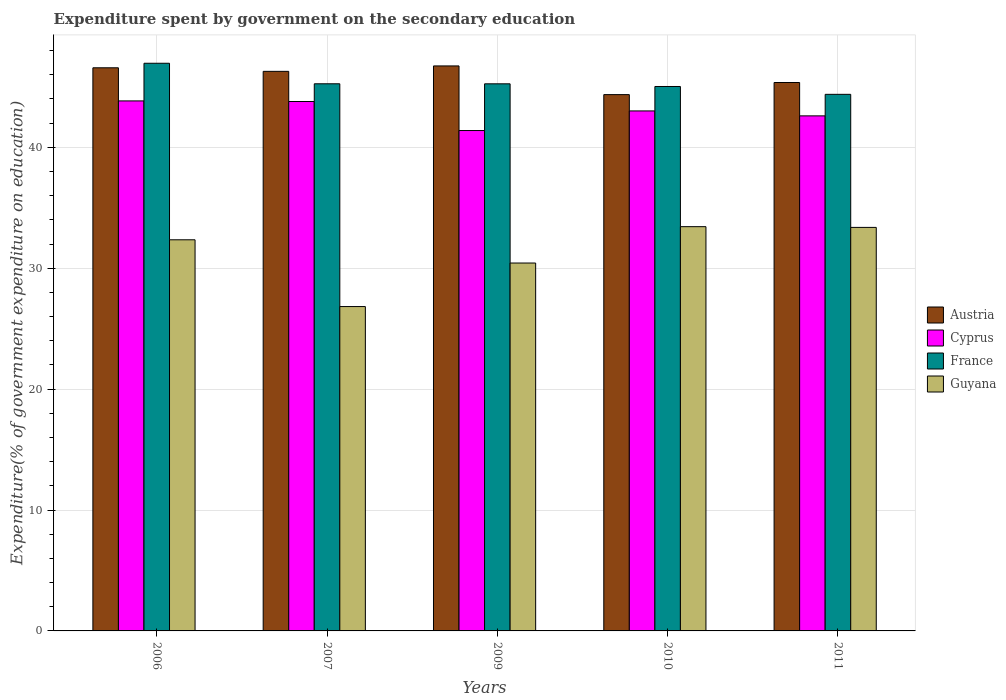How many different coloured bars are there?
Offer a very short reply. 4. How many groups of bars are there?
Your answer should be compact. 5. How many bars are there on the 4th tick from the right?
Offer a terse response. 4. What is the expenditure spent by government on the secondary education in Austria in 2009?
Offer a very short reply. 46.73. Across all years, what is the maximum expenditure spent by government on the secondary education in Austria?
Provide a succinct answer. 46.73. Across all years, what is the minimum expenditure spent by government on the secondary education in France?
Your response must be concise. 44.38. What is the total expenditure spent by government on the secondary education in France in the graph?
Offer a terse response. 226.88. What is the difference between the expenditure spent by government on the secondary education in Guyana in 2006 and that in 2011?
Give a very brief answer. -1.02. What is the difference between the expenditure spent by government on the secondary education in Austria in 2007 and the expenditure spent by government on the secondary education in Guyana in 2011?
Your response must be concise. 12.91. What is the average expenditure spent by government on the secondary education in Austria per year?
Give a very brief answer. 45.86. In the year 2010, what is the difference between the expenditure spent by government on the secondary education in France and expenditure spent by government on the secondary education in Cyprus?
Offer a very short reply. 2.02. In how many years, is the expenditure spent by government on the secondary education in Cyprus greater than 42 %?
Provide a succinct answer. 4. What is the ratio of the expenditure spent by government on the secondary education in Cyprus in 2009 to that in 2011?
Offer a terse response. 0.97. What is the difference between the highest and the second highest expenditure spent by government on the secondary education in Austria?
Offer a very short reply. 0.15. What is the difference between the highest and the lowest expenditure spent by government on the secondary education in Austria?
Offer a terse response. 2.37. In how many years, is the expenditure spent by government on the secondary education in France greater than the average expenditure spent by government on the secondary education in France taken over all years?
Offer a very short reply. 1. Is it the case that in every year, the sum of the expenditure spent by government on the secondary education in France and expenditure spent by government on the secondary education in Austria is greater than the sum of expenditure spent by government on the secondary education in Guyana and expenditure spent by government on the secondary education in Cyprus?
Make the answer very short. Yes. What does the 3rd bar from the left in 2006 represents?
Provide a succinct answer. France. What does the 1st bar from the right in 2009 represents?
Your response must be concise. Guyana. Is it the case that in every year, the sum of the expenditure spent by government on the secondary education in France and expenditure spent by government on the secondary education in Austria is greater than the expenditure spent by government on the secondary education in Guyana?
Provide a succinct answer. Yes. Are all the bars in the graph horizontal?
Provide a short and direct response. No. How many years are there in the graph?
Your answer should be compact. 5. Does the graph contain grids?
Give a very brief answer. Yes. Where does the legend appear in the graph?
Make the answer very short. Center right. How are the legend labels stacked?
Provide a succinct answer. Vertical. What is the title of the graph?
Give a very brief answer. Expenditure spent by government on the secondary education. Does "Lao PDR" appear as one of the legend labels in the graph?
Your answer should be very brief. No. What is the label or title of the Y-axis?
Make the answer very short. Expenditure(% of government expenditure on education). What is the Expenditure(% of government expenditure on education) of Austria in 2006?
Offer a very short reply. 46.58. What is the Expenditure(% of government expenditure on education) of Cyprus in 2006?
Ensure brevity in your answer.  43.84. What is the Expenditure(% of government expenditure on education) of France in 2006?
Provide a succinct answer. 46.95. What is the Expenditure(% of government expenditure on education) in Guyana in 2006?
Your answer should be very brief. 32.35. What is the Expenditure(% of government expenditure on education) of Austria in 2007?
Provide a succinct answer. 46.28. What is the Expenditure(% of government expenditure on education) in Cyprus in 2007?
Provide a short and direct response. 43.79. What is the Expenditure(% of government expenditure on education) of France in 2007?
Give a very brief answer. 45.26. What is the Expenditure(% of government expenditure on education) of Guyana in 2007?
Ensure brevity in your answer.  26.83. What is the Expenditure(% of government expenditure on education) of Austria in 2009?
Make the answer very short. 46.73. What is the Expenditure(% of government expenditure on education) of Cyprus in 2009?
Provide a short and direct response. 41.39. What is the Expenditure(% of government expenditure on education) in France in 2009?
Keep it short and to the point. 45.25. What is the Expenditure(% of government expenditure on education) in Guyana in 2009?
Offer a terse response. 30.43. What is the Expenditure(% of government expenditure on education) in Austria in 2010?
Ensure brevity in your answer.  44.36. What is the Expenditure(% of government expenditure on education) of Cyprus in 2010?
Provide a succinct answer. 43.01. What is the Expenditure(% of government expenditure on education) of France in 2010?
Provide a succinct answer. 45.03. What is the Expenditure(% of government expenditure on education) of Guyana in 2010?
Make the answer very short. 33.44. What is the Expenditure(% of government expenditure on education) in Austria in 2011?
Provide a succinct answer. 45.36. What is the Expenditure(% of government expenditure on education) of Cyprus in 2011?
Your answer should be very brief. 42.6. What is the Expenditure(% of government expenditure on education) in France in 2011?
Provide a short and direct response. 44.38. What is the Expenditure(% of government expenditure on education) in Guyana in 2011?
Your answer should be very brief. 33.38. Across all years, what is the maximum Expenditure(% of government expenditure on education) in Austria?
Provide a succinct answer. 46.73. Across all years, what is the maximum Expenditure(% of government expenditure on education) in Cyprus?
Your answer should be very brief. 43.84. Across all years, what is the maximum Expenditure(% of government expenditure on education) of France?
Your answer should be compact. 46.95. Across all years, what is the maximum Expenditure(% of government expenditure on education) in Guyana?
Ensure brevity in your answer.  33.44. Across all years, what is the minimum Expenditure(% of government expenditure on education) of Austria?
Provide a short and direct response. 44.36. Across all years, what is the minimum Expenditure(% of government expenditure on education) of Cyprus?
Your answer should be very brief. 41.39. Across all years, what is the minimum Expenditure(% of government expenditure on education) of France?
Your response must be concise. 44.38. Across all years, what is the minimum Expenditure(% of government expenditure on education) in Guyana?
Your answer should be compact. 26.83. What is the total Expenditure(% of government expenditure on education) in Austria in the graph?
Make the answer very short. 229.32. What is the total Expenditure(% of government expenditure on education) in Cyprus in the graph?
Your answer should be very brief. 214.63. What is the total Expenditure(% of government expenditure on education) in France in the graph?
Offer a very short reply. 226.88. What is the total Expenditure(% of government expenditure on education) in Guyana in the graph?
Give a very brief answer. 156.43. What is the difference between the Expenditure(% of government expenditure on education) in Austria in 2006 and that in 2007?
Ensure brevity in your answer.  0.29. What is the difference between the Expenditure(% of government expenditure on education) of Cyprus in 2006 and that in 2007?
Keep it short and to the point. 0.05. What is the difference between the Expenditure(% of government expenditure on education) of France in 2006 and that in 2007?
Provide a short and direct response. 1.7. What is the difference between the Expenditure(% of government expenditure on education) of Guyana in 2006 and that in 2007?
Provide a short and direct response. 5.52. What is the difference between the Expenditure(% of government expenditure on education) of Austria in 2006 and that in 2009?
Your answer should be very brief. -0.15. What is the difference between the Expenditure(% of government expenditure on education) in Cyprus in 2006 and that in 2009?
Your response must be concise. 2.45. What is the difference between the Expenditure(% of government expenditure on education) of France in 2006 and that in 2009?
Your answer should be very brief. 1.7. What is the difference between the Expenditure(% of government expenditure on education) in Guyana in 2006 and that in 2009?
Your response must be concise. 1.92. What is the difference between the Expenditure(% of government expenditure on education) of Austria in 2006 and that in 2010?
Ensure brevity in your answer.  2.22. What is the difference between the Expenditure(% of government expenditure on education) of Cyprus in 2006 and that in 2010?
Your response must be concise. 0.83. What is the difference between the Expenditure(% of government expenditure on education) in France in 2006 and that in 2010?
Keep it short and to the point. 1.92. What is the difference between the Expenditure(% of government expenditure on education) in Guyana in 2006 and that in 2010?
Your answer should be compact. -1.09. What is the difference between the Expenditure(% of government expenditure on education) of Austria in 2006 and that in 2011?
Give a very brief answer. 1.22. What is the difference between the Expenditure(% of government expenditure on education) of Cyprus in 2006 and that in 2011?
Ensure brevity in your answer.  1.24. What is the difference between the Expenditure(% of government expenditure on education) in France in 2006 and that in 2011?
Provide a short and direct response. 2.57. What is the difference between the Expenditure(% of government expenditure on education) of Guyana in 2006 and that in 2011?
Your response must be concise. -1.02. What is the difference between the Expenditure(% of government expenditure on education) in Austria in 2007 and that in 2009?
Offer a very short reply. -0.45. What is the difference between the Expenditure(% of government expenditure on education) in Cyprus in 2007 and that in 2009?
Your response must be concise. 2.4. What is the difference between the Expenditure(% of government expenditure on education) in France in 2007 and that in 2009?
Your answer should be very brief. 0. What is the difference between the Expenditure(% of government expenditure on education) of Guyana in 2007 and that in 2009?
Your answer should be compact. -3.6. What is the difference between the Expenditure(% of government expenditure on education) of Austria in 2007 and that in 2010?
Offer a very short reply. 1.92. What is the difference between the Expenditure(% of government expenditure on education) in Cyprus in 2007 and that in 2010?
Keep it short and to the point. 0.78. What is the difference between the Expenditure(% of government expenditure on education) in France in 2007 and that in 2010?
Make the answer very short. 0.22. What is the difference between the Expenditure(% of government expenditure on education) of Guyana in 2007 and that in 2010?
Your answer should be compact. -6.61. What is the difference between the Expenditure(% of government expenditure on education) of Austria in 2007 and that in 2011?
Your answer should be compact. 0.92. What is the difference between the Expenditure(% of government expenditure on education) of Cyprus in 2007 and that in 2011?
Keep it short and to the point. 1.19. What is the difference between the Expenditure(% of government expenditure on education) in France in 2007 and that in 2011?
Give a very brief answer. 0.87. What is the difference between the Expenditure(% of government expenditure on education) in Guyana in 2007 and that in 2011?
Give a very brief answer. -6.55. What is the difference between the Expenditure(% of government expenditure on education) in Austria in 2009 and that in 2010?
Ensure brevity in your answer.  2.37. What is the difference between the Expenditure(% of government expenditure on education) of Cyprus in 2009 and that in 2010?
Ensure brevity in your answer.  -1.62. What is the difference between the Expenditure(% of government expenditure on education) of France in 2009 and that in 2010?
Offer a very short reply. 0.22. What is the difference between the Expenditure(% of government expenditure on education) of Guyana in 2009 and that in 2010?
Your answer should be compact. -3.01. What is the difference between the Expenditure(% of government expenditure on education) of Austria in 2009 and that in 2011?
Offer a terse response. 1.37. What is the difference between the Expenditure(% of government expenditure on education) in Cyprus in 2009 and that in 2011?
Your answer should be very brief. -1.21. What is the difference between the Expenditure(% of government expenditure on education) in France in 2009 and that in 2011?
Provide a succinct answer. 0.87. What is the difference between the Expenditure(% of government expenditure on education) in Guyana in 2009 and that in 2011?
Your response must be concise. -2.95. What is the difference between the Expenditure(% of government expenditure on education) of Austria in 2010 and that in 2011?
Keep it short and to the point. -1. What is the difference between the Expenditure(% of government expenditure on education) in Cyprus in 2010 and that in 2011?
Your response must be concise. 0.41. What is the difference between the Expenditure(% of government expenditure on education) in France in 2010 and that in 2011?
Your answer should be compact. 0.65. What is the difference between the Expenditure(% of government expenditure on education) of Guyana in 2010 and that in 2011?
Keep it short and to the point. 0.06. What is the difference between the Expenditure(% of government expenditure on education) of Austria in 2006 and the Expenditure(% of government expenditure on education) of Cyprus in 2007?
Ensure brevity in your answer.  2.79. What is the difference between the Expenditure(% of government expenditure on education) in Austria in 2006 and the Expenditure(% of government expenditure on education) in France in 2007?
Provide a succinct answer. 1.32. What is the difference between the Expenditure(% of government expenditure on education) of Austria in 2006 and the Expenditure(% of government expenditure on education) of Guyana in 2007?
Provide a short and direct response. 19.75. What is the difference between the Expenditure(% of government expenditure on education) of Cyprus in 2006 and the Expenditure(% of government expenditure on education) of France in 2007?
Keep it short and to the point. -1.42. What is the difference between the Expenditure(% of government expenditure on education) in Cyprus in 2006 and the Expenditure(% of government expenditure on education) in Guyana in 2007?
Your answer should be very brief. 17.01. What is the difference between the Expenditure(% of government expenditure on education) of France in 2006 and the Expenditure(% of government expenditure on education) of Guyana in 2007?
Provide a short and direct response. 20.12. What is the difference between the Expenditure(% of government expenditure on education) of Austria in 2006 and the Expenditure(% of government expenditure on education) of Cyprus in 2009?
Your answer should be compact. 5.19. What is the difference between the Expenditure(% of government expenditure on education) of Austria in 2006 and the Expenditure(% of government expenditure on education) of France in 2009?
Provide a short and direct response. 1.33. What is the difference between the Expenditure(% of government expenditure on education) of Austria in 2006 and the Expenditure(% of government expenditure on education) of Guyana in 2009?
Provide a succinct answer. 16.15. What is the difference between the Expenditure(% of government expenditure on education) in Cyprus in 2006 and the Expenditure(% of government expenditure on education) in France in 2009?
Your answer should be very brief. -1.41. What is the difference between the Expenditure(% of government expenditure on education) in Cyprus in 2006 and the Expenditure(% of government expenditure on education) in Guyana in 2009?
Your answer should be compact. 13.41. What is the difference between the Expenditure(% of government expenditure on education) in France in 2006 and the Expenditure(% of government expenditure on education) in Guyana in 2009?
Provide a succinct answer. 16.52. What is the difference between the Expenditure(% of government expenditure on education) in Austria in 2006 and the Expenditure(% of government expenditure on education) in Cyprus in 2010?
Your answer should be very brief. 3.57. What is the difference between the Expenditure(% of government expenditure on education) in Austria in 2006 and the Expenditure(% of government expenditure on education) in France in 2010?
Your response must be concise. 1.55. What is the difference between the Expenditure(% of government expenditure on education) in Austria in 2006 and the Expenditure(% of government expenditure on education) in Guyana in 2010?
Give a very brief answer. 13.14. What is the difference between the Expenditure(% of government expenditure on education) in Cyprus in 2006 and the Expenditure(% of government expenditure on education) in France in 2010?
Give a very brief answer. -1.19. What is the difference between the Expenditure(% of government expenditure on education) in Cyprus in 2006 and the Expenditure(% of government expenditure on education) in Guyana in 2010?
Ensure brevity in your answer.  10.4. What is the difference between the Expenditure(% of government expenditure on education) in France in 2006 and the Expenditure(% of government expenditure on education) in Guyana in 2010?
Keep it short and to the point. 13.52. What is the difference between the Expenditure(% of government expenditure on education) of Austria in 2006 and the Expenditure(% of government expenditure on education) of Cyprus in 2011?
Your answer should be compact. 3.98. What is the difference between the Expenditure(% of government expenditure on education) in Austria in 2006 and the Expenditure(% of government expenditure on education) in France in 2011?
Keep it short and to the point. 2.2. What is the difference between the Expenditure(% of government expenditure on education) in Austria in 2006 and the Expenditure(% of government expenditure on education) in Guyana in 2011?
Keep it short and to the point. 13.2. What is the difference between the Expenditure(% of government expenditure on education) of Cyprus in 2006 and the Expenditure(% of government expenditure on education) of France in 2011?
Provide a succinct answer. -0.54. What is the difference between the Expenditure(% of government expenditure on education) in Cyprus in 2006 and the Expenditure(% of government expenditure on education) in Guyana in 2011?
Your answer should be very brief. 10.46. What is the difference between the Expenditure(% of government expenditure on education) in France in 2006 and the Expenditure(% of government expenditure on education) in Guyana in 2011?
Provide a short and direct response. 13.58. What is the difference between the Expenditure(% of government expenditure on education) in Austria in 2007 and the Expenditure(% of government expenditure on education) in Cyprus in 2009?
Your response must be concise. 4.89. What is the difference between the Expenditure(% of government expenditure on education) in Austria in 2007 and the Expenditure(% of government expenditure on education) in France in 2009?
Your answer should be very brief. 1.03. What is the difference between the Expenditure(% of government expenditure on education) in Austria in 2007 and the Expenditure(% of government expenditure on education) in Guyana in 2009?
Provide a succinct answer. 15.85. What is the difference between the Expenditure(% of government expenditure on education) of Cyprus in 2007 and the Expenditure(% of government expenditure on education) of France in 2009?
Make the answer very short. -1.46. What is the difference between the Expenditure(% of government expenditure on education) in Cyprus in 2007 and the Expenditure(% of government expenditure on education) in Guyana in 2009?
Your response must be concise. 13.36. What is the difference between the Expenditure(% of government expenditure on education) in France in 2007 and the Expenditure(% of government expenditure on education) in Guyana in 2009?
Provide a succinct answer. 14.83. What is the difference between the Expenditure(% of government expenditure on education) of Austria in 2007 and the Expenditure(% of government expenditure on education) of Cyprus in 2010?
Your response must be concise. 3.27. What is the difference between the Expenditure(% of government expenditure on education) in Austria in 2007 and the Expenditure(% of government expenditure on education) in France in 2010?
Your response must be concise. 1.25. What is the difference between the Expenditure(% of government expenditure on education) in Austria in 2007 and the Expenditure(% of government expenditure on education) in Guyana in 2010?
Keep it short and to the point. 12.85. What is the difference between the Expenditure(% of government expenditure on education) in Cyprus in 2007 and the Expenditure(% of government expenditure on education) in France in 2010?
Provide a short and direct response. -1.24. What is the difference between the Expenditure(% of government expenditure on education) in Cyprus in 2007 and the Expenditure(% of government expenditure on education) in Guyana in 2010?
Provide a succinct answer. 10.35. What is the difference between the Expenditure(% of government expenditure on education) of France in 2007 and the Expenditure(% of government expenditure on education) of Guyana in 2010?
Provide a succinct answer. 11.82. What is the difference between the Expenditure(% of government expenditure on education) of Austria in 2007 and the Expenditure(% of government expenditure on education) of Cyprus in 2011?
Offer a very short reply. 3.68. What is the difference between the Expenditure(% of government expenditure on education) in Austria in 2007 and the Expenditure(% of government expenditure on education) in France in 2011?
Offer a very short reply. 1.9. What is the difference between the Expenditure(% of government expenditure on education) of Austria in 2007 and the Expenditure(% of government expenditure on education) of Guyana in 2011?
Provide a succinct answer. 12.91. What is the difference between the Expenditure(% of government expenditure on education) of Cyprus in 2007 and the Expenditure(% of government expenditure on education) of France in 2011?
Give a very brief answer. -0.59. What is the difference between the Expenditure(% of government expenditure on education) in Cyprus in 2007 and the Expenditure(% of government expenditure on education) in Guyana in 2011?
Provide a succinct answer. 10.41. What is the difference between the Expenditure(% of government expenditure on education) in France in 2007 and the Expenditure(% of government expenditure on education) in Guyana in 2011?
Your answer should be very brief. 11.88. What is the difference between the Expenditure(% of government expenditure on education) of Austria in 2009 and the Expenditure(% of government expenditure on education) of Cyprus in 2010?
Offer a very short reply. 3.72. What is the difference between the Expenditure(% of government expenditure on education) in Austria in 2009 and the Expenditure(% of government expenditure on education) in France in 2010?
Give a very brief answer. 1.7. What is the difference between the Expenditure(% of government expenditure on education) in Austria in 2009 and the Expenditure(% of government expenditure on education) in Guyana in 2010?
Offer a terse response. 13.29. What is the difference between the Expenditure(% of government expenditure on education) in Cyprus in 2009 and the Expenditure(% of government expenditure on education) in France in 2010?
Provide a succinct answer. -3.64. What is the difference between the Expenditure(% of government expenditure on education) in Cyprus in 2009 and the Expenditure(% of government expenditure on education) in Guyana in 2010?
Offer a terse response. 7.95. What is the difference between the Expenditure(% of government expenditure on education) of France in 2009 and the Expenditure(% of government expenditure on education) of Guyana in 2010?
Your answer should be very brief. 11.82. What is the difference between the Expenditure(% of government expenditure on education) of Austria in 2009 and the Expenditure(% of government expenditure on education) of Cyprus in 2011?
Provide a short and direct response. 4.13. What is the difference between the Expenditure(% of government expenditure on education) of Austria in 2009 and the Expenditure(% of government expenditure on education) of France in 2011?
Your response must be concise. 2.35. What is the difference between the Expenditure(% of government expenditure on education) in Austria in 2009 and the Expenditure(% of government expenditure on education) in Guyana in 2011?
Offer a terse response. 13.36. What is the difference between the Expenditure(% of government expenditure on education) in Cyprus in 2009 and the Expenditure(% of government expenditure on education) in France in 2011?
Keep it short and to the point. -2.99. What is the difference between the Expenditure(% of government expenditure on education) of Cyprus in 2009 and the Expenditure(% of government expenditure on education) of Guyana in 2011?
Your answer should be compact. 8.01. What is the difference between the Expenditure(% of government expenditure on education) in France in 2009 and the Expenditure(% of government expenditure on education) in Guyana in 2011?
Provide a short and direct response. 11.88. What is the difference between the Expenditure(% of government expenditure on education) of Austria in 2010 and the Expenditure(% of government expenditure on education) of Cyprus in 2011?
Offer a terse response. 1.76. What is the difference between the Expenditure(% of government expenditure on education) in Austria in 2010 and the Expenditure(% of government expenditure on education) in France in 2011?
Your response must be concise. -0.02. What is the difference between the Expenditure(% of government expenditure on education) of Austria in 2010 and the Expenditure(% of government expenditure on education) of Guyana in 2011?
Offer a terse response. 10.98. What is the difference between the Expenditure(% of government expenditure on education) of Cyprus in 2010 and the Expenditure(% of government expenditure on education) of France in 2011?
Your answer should be very brief. -1.37. What is the difference between the Expenditure(% of government expenditure on education) of Cyprus in 2010 and the Expenditure(% of government expenditure on education) of Guyana in 2011?
Keep it short and to the point. 9.63. What is the difference between the Expenditure(% of government expenditure on education) of France in 2010 and the Expenditure(% of government expenditure on education) of Guyana in 2011?
Your answer should be compact. 11.66. What is the average Expenditure(% of government expenditure on education) of Austria per year?
Your answer should be compact. 45.86. What is the average Expenditure(% of government expenditure on education) in Cyprus per year?
Offer a terse response. 42.93. What is the average Expenditure(% of government expenditure on education) in France per year?
Offer a very short reply. 45.38. What is the average Expenditure(% of government expenditure on education) in Guyana per year?
Offer a very short reply. 31.29. In the year 2006, what is the difference between the Expenditure(% of government expenditure on education) in Austria and Expenditure(% of government expenditure on education) in Cyprus?
Keep it short and to the point. 2.74. In the year 2006, what is the difference between the Expenditure(% of government expenditure on education) of Austria and Expenditure(% of government expenditure on education) of France?
Make the answer very short. -0.37. In the year 2006, what is the difference between the Expenditure(% of government expenditure on education) of Austria and Expenditure(% of government expenditure on education) of Guyana?
Provide a short and direct response. 14.23. In the year 2006, what is the difference between the Expenditure(% of government expenditure on education) of Cyprus and Expenditure(% of government expenditure on education) of France?
Your answer should be compact. -3.11. In the year 2006, what is the difference between the Expenditure(% of government expenditure on education) in Cyprus and Expenditure(% of government expenditure on education) in Guyana?
Your answer should be very brief. 11.49. In the year 2006, what is the difference between the Expenditure(% of government expenditure on education) in France and Expenditure(% of government expenditure on education) in Guyana?
Your response must be concise. 14.6. In the year 2007, what is the difference between the Expenditure(% of government expenditure on education) in Austria and Expenditure(% of government expenditure on education) in Cyprus?
Offer a very short reply. 2.49. In the year 2007, what is the difference between the Expenditure(% of government expenditure on education) of Austria and Expenditure(% of government expenditure on education) of France?
Keep it short and to the point. 1.03. In the year 2007, what is the difference between the Expenditure(% of government expenditure on education) of Austria and Expenditure(% of government expenditure on education) of Guyana?
Your response must be concise. 19.45. In the year 2007, what is the difference between the Expenditure(% of government expenditure on education) of Cyprus and Expenditure(% of government expenditure on education) of France?
Ensure brevity in your answer.  -1.47. In the year 2007, what is the difference between the Expenditure(% of government expenditure on education) in Cyprus and Expenditure(% of government expenditure on education) in Guyana?
Your answer should be compact. 16.96. In the year 2007, what is the difference between the Expenditure(% of government expenditure on education) of France and Expenditure(% of government expenditure on education) of Guyana?
Ensure brevity in your answer.  18.43. In the year 2009, what is the difference between the Expenditure(% of government expenditure on education) in Austria and Expenditure(% of government expenditure on education) in Cyprus?
Provide a succinct answer. 5.34. In the year 2009, what is the difference between the Expenditure(% of government expenditure on education) in Austria and Expenditure(% of government expenditure on education) in France?
Provide a succinct answer. 1.48. In the year 2009, what is the difference between the Expenditure(% of government expenditure on education) of Austria and Expenditure(% of government expenditure on education) of Guyana?
Your answer should be very brief. 16.3. In the year 2009, what is the difference between the Expenditure(% of government expenditure on education) of Cyprus and Expenditure(% of government expenditure on education) of France?
Provide a succinct answer. -3.86. In the year 2009, what is the difference between the Expenditure(% of government expenditure on education) of Cyprus and Expenditure(% of government expenditure on education) of Guyana?
Offer a terse response. 10.96. In the year 2009, what is the difference between the Expenditure(% of government expenditure on education) in France and Expenditure(% of government expenditure on education) in Guyana?
Provide a short and direct response. 14.82. In the year 2010, what is the difference between the Expenditure(% of government expenditure on education) in Austria and Expenditure(% of government expenditure on education) in Cyprus?
Ensure brevity in your answer.  1.35. In the year 2010, what is the difference between the Expenditure(% of government expenditure on education) of Austria and Expenditure(% of government expenditure on education) of France?
Make the answer very short. -0.67. In the year 2010, what is the difference between the Expenditure(% of government expenditure on education) in Austria and Expenditure(% of government expenditure on education) in Guyana?
Offer a very short reply. 10.92. In the year 2010, what is the difference between the Expenditure(% of government expenditure on education) of Cyprus and Expenditure(% of government expenditure on education) of France?
Your answer should be compact. -2.02. In the year 2010, what is the difference between the Expenditure(% of government expenditure on education) in Cyprus and Expenditure(% of government expenditure on education) in Guyana?
Your answer should be compact. 9.57. In the year 2010, what is the difference between the Expenditure(% of government expenditure on education) of France and Expenditure(% of government expenditure on education) of Guyana?
Your answer should be compact. 11.59. In the year 2011, what is the difference between the Expenditure(% of government expenditure on education) in Austria and Expenditure(% of government expenditure on education) in Cyprus?
Your answer should be very brief. 2.76. In the year 2011, what is the difference between the Expenditure(% of government expenditure on education) in Austria and Expenditure(% of government expenditure on education) in France?
Your response must be concise. 0.98. In the year 2011, what is the difference between the Expenditure(% of government expenditure on education) in Austria and Expenditure(% of government expenditure on education) in Guyana?
Offer a very short reply. 11.98. In the year 2011, what is the difference between the Expenditure(% of government expenditure on education) in Cyprus and Expenditure(% of government expenditure on education) in France?
Offer a terse response. -1.78. In the year 2011, what is the difference between the Expenditure(% of government expenditure on education) in Cyprus and Expenditure(% of government expenditure on education) in Guyana?
Your answer should be very brief. 9.23. In the year 2011, what is the difference between the Expenditure(% of government expenditure on education) in France and Expenditure(% of government expenditure on education) in Guyana?
Provide a short and direct response. 11.01. What is the ratio of the Expenditure(% of government expenditure on education) of Austria in 2006 to that in 2007?
Offer a very short reply. 1.01. What is the ratio of the Expenditure(% of government expenditure on education) in Cyprus in 2006 to that in 2007?
Ensure brevity in your answer.  1. What is the ratio of the Expenditure(% of government expenditure on education) in France in 2006 to that in 2007?
Ensure brevity in your answer.  1.04. What is the ratio of the Expenditure(% of government expenditure on education) in Guyana in 2006 to that in 2007?
Ensure brevity in your answer.  1.21. What is the ratio of the Expenditure(% of government expenditure on education) of Austria in 2006 to that in 2009?
Ensure brevity in your answer.  1. What is the ratio of the Expenditure(% of government expenditure on education) in Cyprus in 2006 to that in 2009?
Give a very brief answer. 1.06. What is the ratio of the Expenditure(% of government expenditure on education) in France in 2006 to that in 2009?
Your answer should be very brief. 1.04. What is the ratio of the Expenditure(% of government expenditure on education) in Guyana in 2006 to that in 2009?
Give a very brief answer. 1.06. What is the ratio of the Expenditure(% of government expenditure on education) of Cyprus in 2006 to that in 2010?
Make the answer very short. 1.02. What is the ratio of the Expenditure(% of government expenditure on education) of France in 2006 to that in 2010?
Provide a short and direct response. 1.04. What is the ratio of the Expenditure(% of government expenditure on education) in Guyana in 2006 to that in 2010?
Your answer should be compact. 0.97. What is the ratio of the Expenditure(% of government expenditure on education) of Austria in 2006 to that in 2011?
Give a very brief answer. 1.03. What is the ratio of the Expenditure(% of government expenditure on education) in Cyprus in 2006 to that in 2011?
Offer a very short reply. 1.03. What is the ratio of the Expenditure(% of government expenditure on education) of France in 2006 to that in 2011?
Provide a short and direct response. 1.06. What is the ratio of the Expenditure(% of government expenditure on education) in Guyana in 2006 to that in 2011?
Offer a terse response. 0.97. What is the ratio of the Expenditure(% of government expenditure on education) of Cyprus in 2007 to that in 2009?
Keep it short and to the point. 1.06. What is the ratio of the Expenditure(% of government expenditure on education) in France in 2007 to that in 2009?
Keep it short and to the point. 1. What is the ratio of the Expenditure(% of government expenditure on education) of Guyana in 2007 to that in 2009?
Make the answer very short. 0.88. What is the ratio of the Expenditure(% of government expenditure on education) of Austria in 2007 to that in 2010?
Your response must be concise. 1.04. What is the ratio of the Expenditure(% of government expenditure on education) of Cyprus in 2007 to that in 2010?
Offer a terse response. 1.02. What is the ratio of the Expenditure(% of government expenditure on education) of Guyana in 2007 to that in 2010?
Your answer should be very brief. 0.8. What is the ratio of the Expenditure(% of government expenditure on education) in Austria in 2007 to that in 2011?
Keep it short and to the point. 1.02. What is the ratio of the Expenditure(% of government expenditure on education) in Cyprus in 2007 to that in 2011?
Provide a succinct answer. 1.03. What is the ratio of the Expenditure(% of government expenditure on education) in France in 2007 to that in 2011?
Give a very brief answer. 1.02. What is the ratio of the Expenditure(% of government expenditure on education) of Guyana in 2007 to that in 2011?
Your response must be concise. 0.8. What is the ratio of the Expenditure(% of government expenditure on education) of Austria in 2009 to that in 2010?
Offer a very short reply. 1.05. What is the ratio of the Expenditure(% of government expenditure on education) in Cyprus in 2009 to that in 2010?
Provide a succinct answer. 0.96. What is the ratio of the Expenditure(% of government expenditure on education) in Guyana in 2009 to that in 2010?
Provide a succinct answer. 0.91. What is the ratio of the Expenditure(% of government expenditure on education) of Austria in 2009 to that in 2011?
Provide a succinct answer. 1.03. What is the ratio of the Expenditure(% of government expenditure on education) of Cyprus in 2009 to that in 2011?
Your response must be concise. 0.97. What is the ratio of the Expenditure(% of government expenditure on education) of France in 2009 to that in 2011?
Offer a very short reply. 1.02. What is the ratio of the Expenditure(% of government expenditure on education) of Guyana in 2009 to that in 2011?
Ensure brevity in your answer.  0.91. What is the ratio of the Expenditure(% of government expenditure on education) of Austria in 2010 to that in 2011?
Offer a terse response. 0.98. What is the ratio of the Expenditure(% of government expenditure on education) of Cyprus in 2010 to that in 2011?
Keep it short and to the point. 1.01. What is the ratio of the Expenditure(% of government expenditure on education) in France in 2010 to that in 2011?
Provide a succinct answer. 1.01. What is the difference between the highest and the second highest Expenditure(% of government expenditure on education) in Austria?
Your answer should be compact. 0.15. What is the difference between the highest and the second highest Expenditure(% of government expenditure on education) in Cyprus?
Your response must be concise. 0.05. What is the difference between the highest and the second highest Expenditure(% of government expenditure on education) of France?
Your response must be concise. 1.7. What is the difference between the highest and the second highest Expenditure(% of government expenditure on education) in Guyana?
Ensure brevity in your answer.  0.06. What is the difference between the highest and the lowest Expenditure(% of government expenditure on education) in Austria?
Make the answer very short. 2.37. What is the difference between the highest and the lowest Expenditure(% of government expenditure on education) in Cyprus?
Ensure brevity in your answer.  2.45. What is the difference between the highest and the lowest Expenditure(% of government expenditure on education) in France?
Your response must be concise. 2.57. What is the difference between the highest and the lowest Expenditure(% of government expenditure on education) of Guyana?
Ensure brevity in your answer.  6.61. 